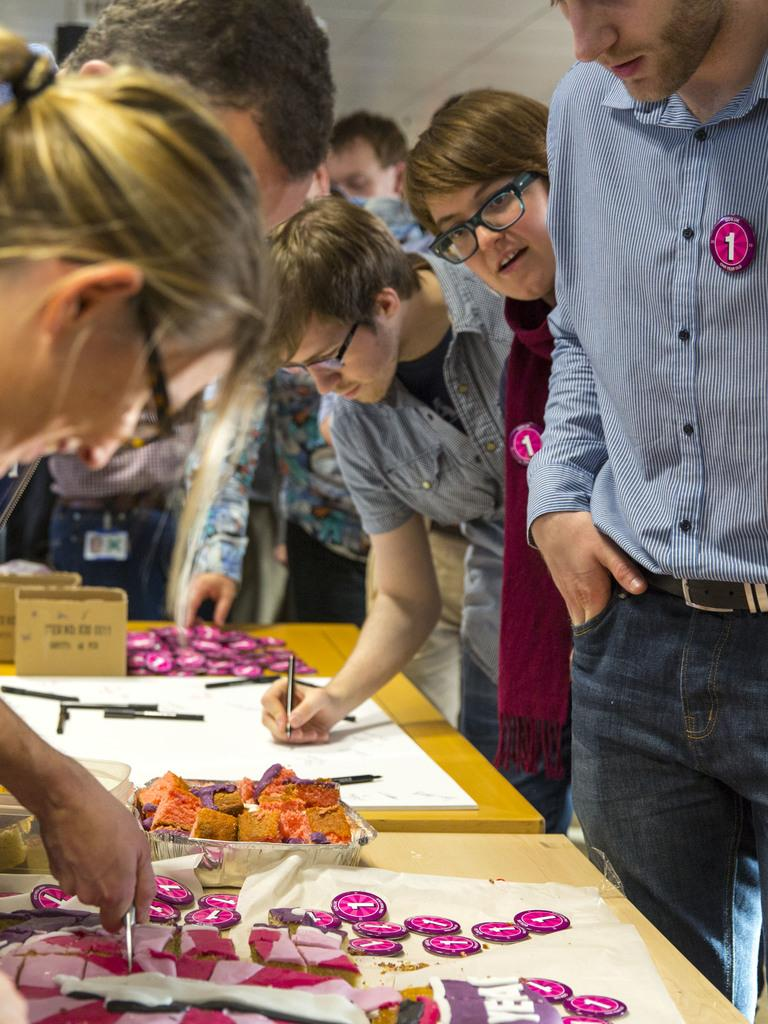How many people are in the image? There is a group of people in the image. What are the people in the image doing? The people are standing together. What is on the table in the image? There is a table in the image, and there is a person drawing on paper on the table. What else can be seen on the table? There are objects on the table. What color is the balloon that the person is holding in the image? There is no balloon present in the image. How does the person wearing the hat interact with the skate in the image? There is no hat or skate present in the image. 